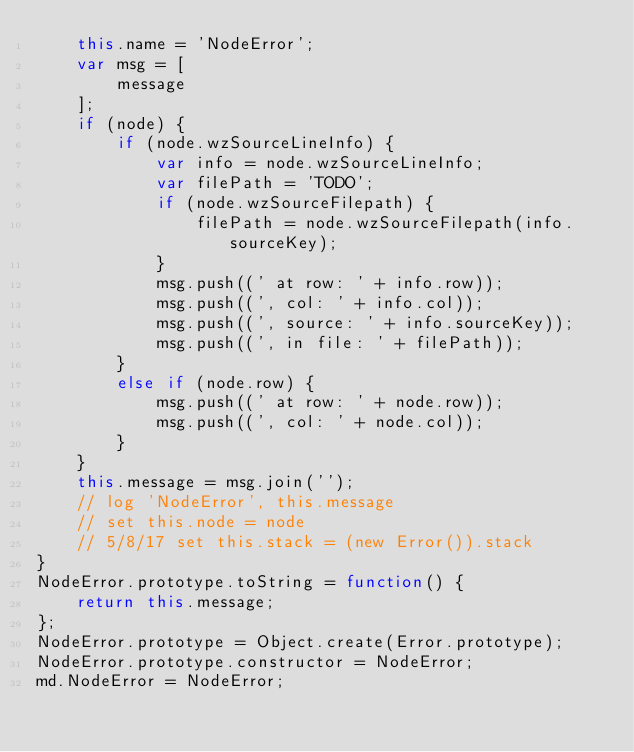Convert code to text. <code><loc_0><loc_0><loc_500><loc_500><_JavaScript_>    this.name = 'NodeError';
    var msg = [
        message
    ];
    if (node) {
        if (node.wzSourceLineInfo) {
            var info = node.wzSourceLineInfo;
            var filePath = 'TODO';
            if (node.wzSourceFilepath) {
                filePath = node.wzSourceFilepath(info.sourceKey);
            }
            msg.push((' at row: ' + info.row));
            msg.push((', col: ' + info.col));
            msg.push((', source: ' + info.sourceKey));
            msg.push((', in file: ' + filePath));
        }
        else if (node.row) {
            msg.push((' at row: ' + node.row));
            msg.push((', col: ' + node.col));
        }
    }
    this.message = msg.join('');
    // log 'NodeError', this.message
    // set this.node = node
    // 5/8/17 set this.stack = (new Error()).stack
}
NodeError.prototype.toString = function() {
    return this.message;
};
NodeError.prototype = Object.create(Error.prototype);
NodeError.prototype.constructor = NodeError;
md.NodeError = NodeError;

</code> 